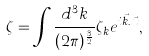Convert formula to latex. <formula><loc_0><loc_0><loc_500><loc_500>\zeta = \int \frac { d ^ { 3 } k } { ( 2 \pi ) ^ { \frac { 3 } { 2 } } } \zeta _ { k } e ^ { i \vec { k } . \vec { x } } ,</formula> 